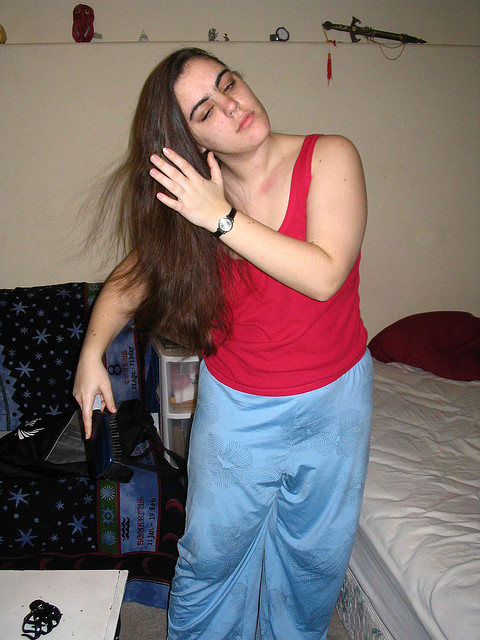Please identify all text content in this image. 8 